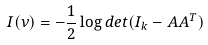Convert formula to latex. <formula><loc_0><loc_0><loc_500><loc_500>I ( \nu ) = - \frac { 1 } { 2 } \log d e t ( I _ { k } - A A ^ { T } )</formula> 